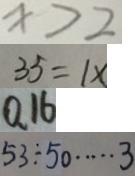Convert formula to latex. <formula><loc_0><loc_0><loc_500><loc_500>x > 2 
 3 5 = 1 x 
 0 . 1 6 
 5 3 \div 5 0 \cdots 3</formula> 